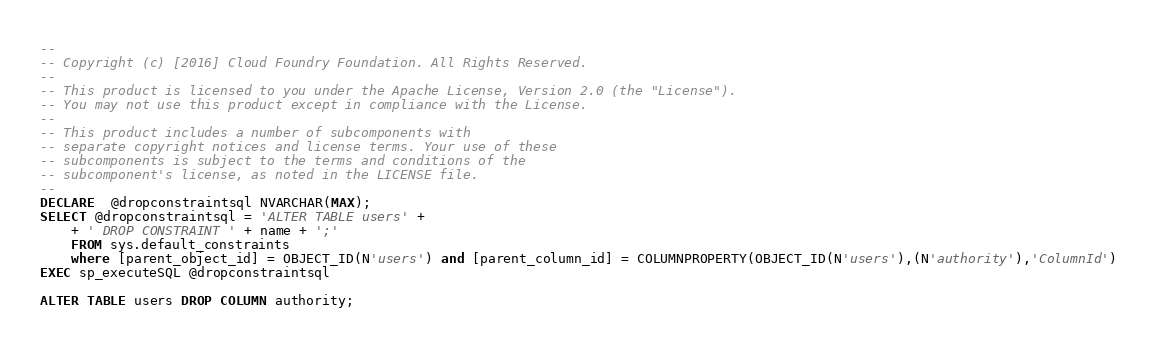<code> <loc_0><loc_0><loc_500><loc_500><_SQL_>--
-- Copyright (c) [2016] Cloud Foundry Foundation. All Rights Reserved.
--
-- This product is licensed to you under the Apache License, Version 2.0 (the "License").
-- You may not use this product except in compliance with the License.
--
-- This product includes a number of subcomponents with
-- separate copyright notices and license terms. Your use of these
-- subcomponents is subject to the terms and conditions of the
-- subcomponent's license, as noted in the LICENSE file.
--
DECLARE  @dropconstraintsql NVARCHAR(MAX);
SELECT @dropconstraintsql = 'ALTER TABLE users' +
    + ' DROP CONSTRAINT ' + name + ';'
    FROM sys.default_constraints
    where [parent_object_id] = OBJECT_ID(N'users') and [parent_column_id] = COLUMNPROPERTY(OBJECT_ID(N'users'),(N'authority'),'ColumnId')
EXEC sp_executeSQL @dropconstraintsql

ALTER TABLE users DROP COLUMN authority;</code> 